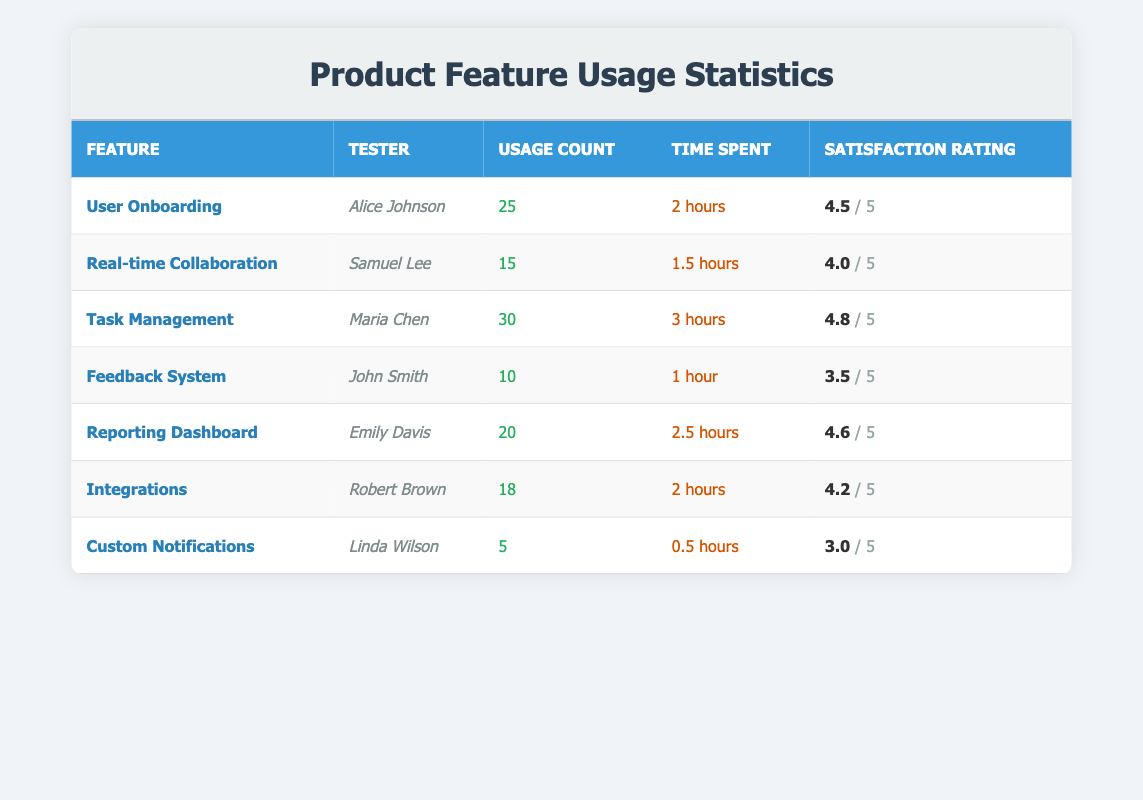What is the usage count for the feature "User Onboarding"? The table shows the usage count for "User Onboarding" to be 25 from the row corresponding to Alice Johnson.
Answer: 25 Which feature received the highest satisfaction rating? By examining the satisfaction ratings in the table, "Task Management," with a rating of 4.8 from Maria Chen, is identified as having the highest rating.
Answer: Task Management What is the total time spent by all the testers on the "Integrations" feature? Looking at the specific entry for "Integrations," Robert Brown spent 2 hours using that feature, so the total is 2 hours as there's only one tester.
Answer: 2 hours Which tester spent the least amount of time and how much was it? The table indicates that Linda Wilson, who used "Custom Notifications," spent only 0.5 hours, the least time compared to others.
Answer: 0.5 hours Is the satisfaction rating for the "Feedback System" above 4? The table records a satisfaction rating of 3.5 for the "Feedback System," which is below 4, thus the answer is no.
Answer: No What is the average usage count for all features combined? The usage counts are 25, 15, 30, 10, 20, 18, and 5, adding these gives 25 + 15 + 30 + 10 + 20 + 18 + 5 = 123, and dividing by 7 (the number of features) yields an average of approximately 17.57.
Answer: 17.57 Who had the highest satisfaction rating and what was it? The maximum satisfaction rating of 4.8 is seen in the "Task Management" feature used by Maria Chen, which indicates she had the highest rating.
Answer: Maria Chen, 4.8 What is the difference in usage count between "Task Management" and "Custom Notifications"? The usage for "Task Management" is 30 and for "Custom Notifications" is 5, therefore the difference is 30 - 5 = 25.
Answer: 25 